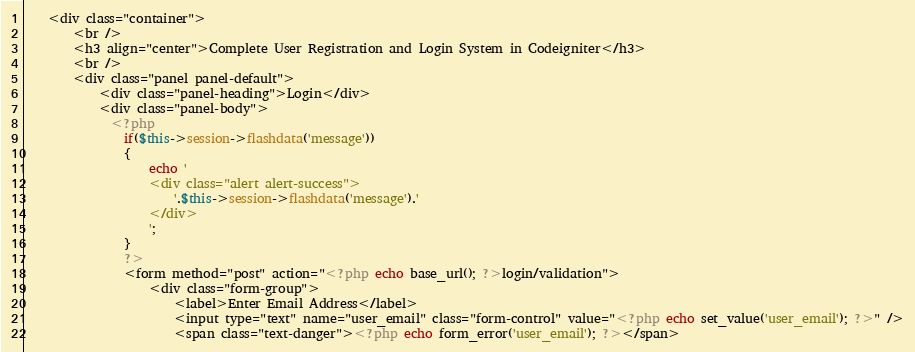Convert code to text. <code><loc_0><loc_0><loc_500><loc_500><_PHP_>    <div class="container">
        <br />
        <h3 align="center">Complete User Registration and Login System in Codeigniter</h3>
        <br />
        <div class="panel panel-default">
            <div class="panel-heading">Login</div>
            <div class="panel-body">
              <?php   
                if($this->session->flashdata('message'))
                {
                    echo '
                    <div class="alert alert-success">
                        '.$this->session->flashdata('message').'
                    </div>
                    ';
                }
                ?> 
                <form method="post" action="<?php echo base_url(); ?>login/validation">
                    <div class="form-group">
                        <label>Enter Email Address</label>
                        <input type="text" name="user_email" class="form-control" value="<?php echo set_value('user_email'); ?>" />
                        <span class="text-danger"><?php echo form_error('user_email'); ?></span></code> 